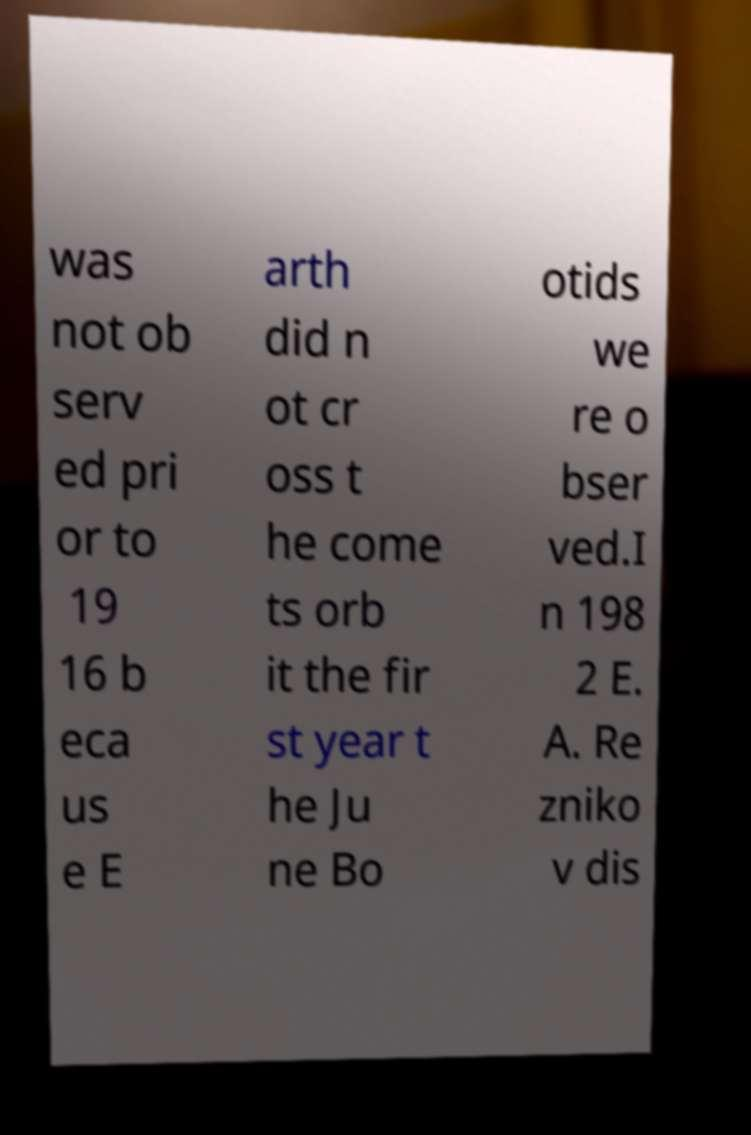For documentation purposes, I need the text within this image transcribed. Could you provide that? was not ob serv ed pri or to 19 16 b eca us e E arth did n ot cr oss t he come ts orb it the fir st year t he Ju ne Bo otids we re o bser ved.I n 198 2 E. A. Re zniko v dis 